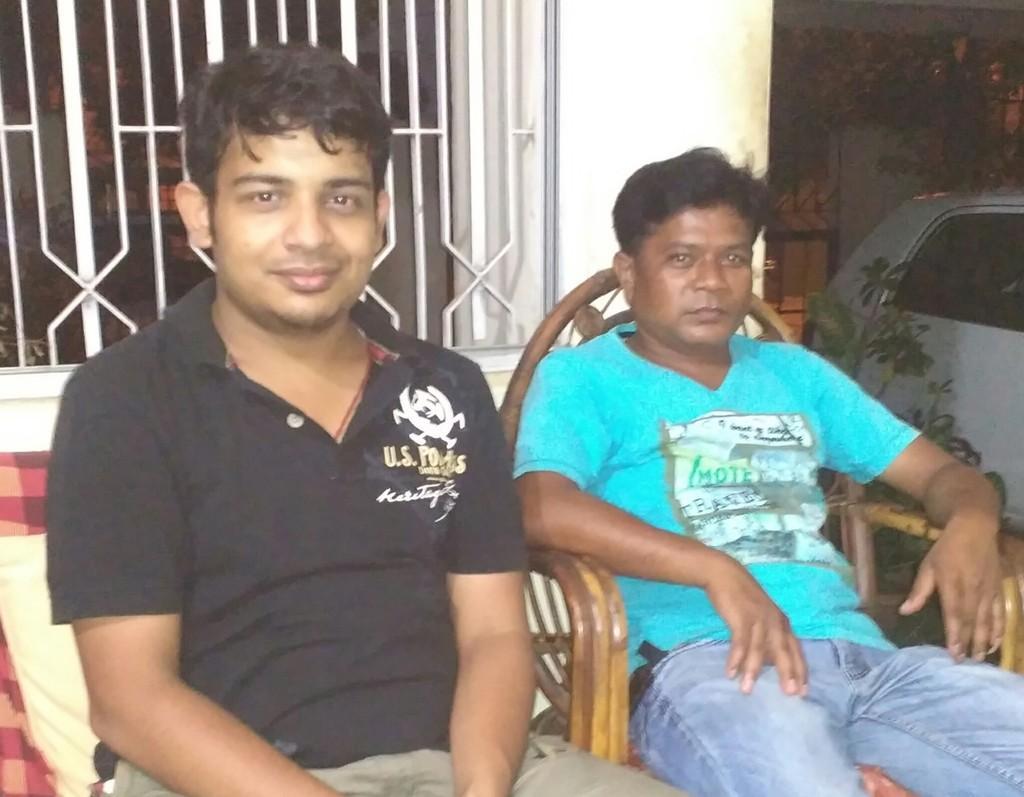Please provide a concise description of this image. In this image I can see two people sitting on the chairs. These people are wearing the different color dresses. To the right I can see the white color car. In the back I can see the window and the bushes. 